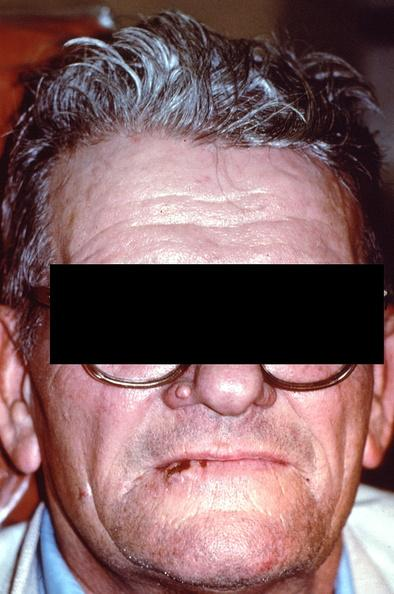s lesion in dome of uterus present?
Answer the question using a single word or phrase. No 